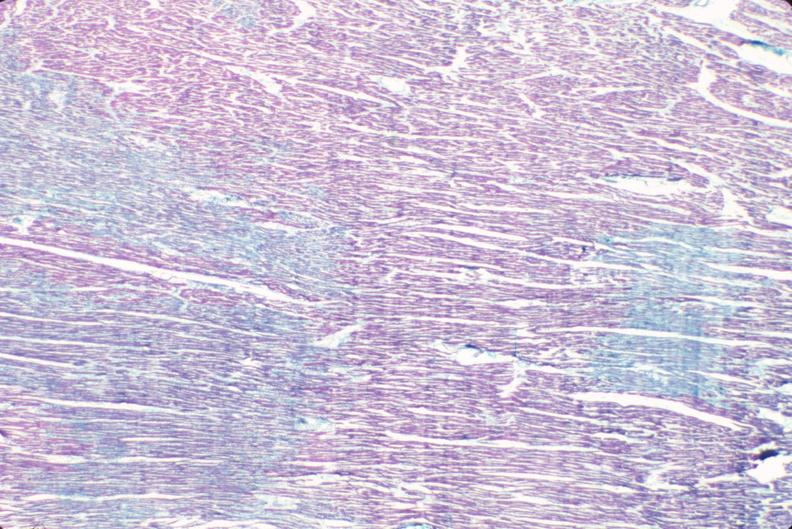s cardiovascular present?
Answer the question using a single word or phrase. Yes 